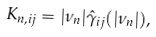<formula> <loc_0><loc_0><loc_500><loc_500>K _ { n , { i j } } = | \nu _ { n } | { \hat { \gamma } } _ { i j } ( | \nu _ { n } | ) ,</formula> 